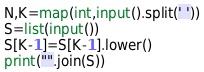Convert code to text. <code><loc_0><loc_0><loc_500><loc_500><_Python_>N,K=map(int,input().split(' '))
S=list(input())
S[K-1]=S[K-1].lower()
print("".join(S))</code> 